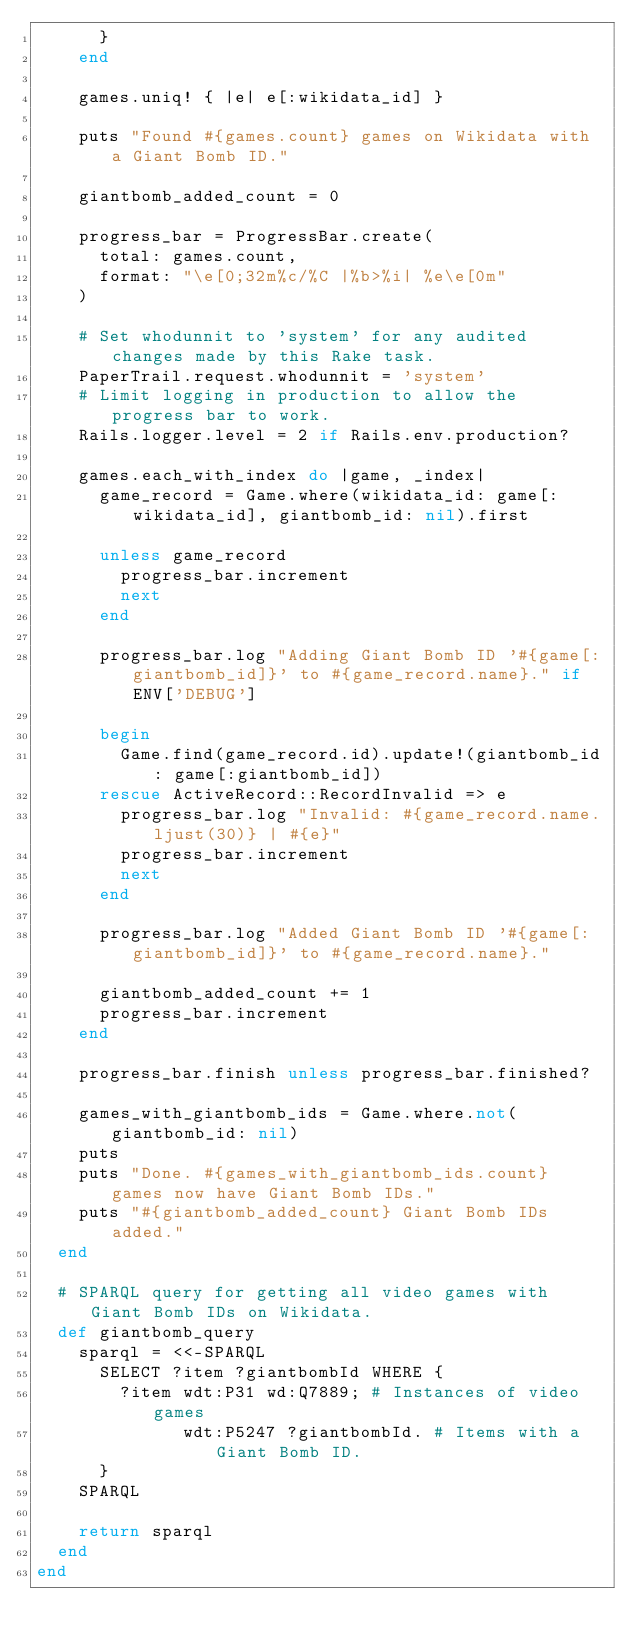<code> <loc_0><loc_0><loc_500><loc_500><_Ruby_>      }
    end

    games.uniq! { |e| e[:wikidata_id] }

    puts "Found #{games.count} games on Wikidata with a Giant Bomb ID."

    giantbomb_added_count = 0

    progress_bar = ProgressBar.create(
      total: games.count,
      format: "\e[0;32m%c/%C |%b>%i| %e\e[0m"
    )

    # Set whodunnit to 'system' for any audited changes made by this Rake task.
    PaperTrail.request.whodunnit = 'system'
    # Limit logging in production to allow the progress bar to work.
    Rails.logger.level = 2 if Rails.env.production?

    games.each_with_index do |game, _index|
      game_record = Game.where(wikidata_id: game[:wikidata_id], giantbomb_id: nil).first

      unless game_record
        progress_bar.increment
        next
      end

      progress_bar.log "Adding Giant Bomb ID '#{game[:giantbomb_id]}' to #{game_record.name}." if ENV['DEBUG']

      begin
        Game.find(game_record.id).update!(giantbomb_id: game[:giantbomb_id])
      rescue ActiveRecord::RecordInvalid => e
        progress_bar.log "Invalid: #{game_record.name.ljust(30)} | #{e}"
        progress_bar.increment
        next
      end

      progress_bar.log "Added Giant Bomb ID '#{game[:giantbomb_id]}' to #{game_record.name}."

      giantbomb_added_count += 1
      progress_bar.increment
    end

    progress_bar.finish unless progress_bar.finished?

    games_with_giantbomb_ids = Game.where.not(giantbomb_id: nil)
    puts
    puts "Done. #{games_with_giantbomb_ids.count} games now have Giant Bomb IDs."
    puts "#{giantbomb_added_count} Giant Bomb IDs added."
  end

  # SPARQL query for getting all video games with Giant Bomb IDs on Wikidata.
  def giantbomb_query
    sparql = <<-SPARQL
      SELECT ?item ?giantbombId WHERE {
        ?item wdt:P31 wd:Q7889; # Instances of video games
              wdt:P5247 ?giantbombId. # Items with a Giant Bomb ID.
      }
    SPARQL

    return sparql
  end
end
</code> 